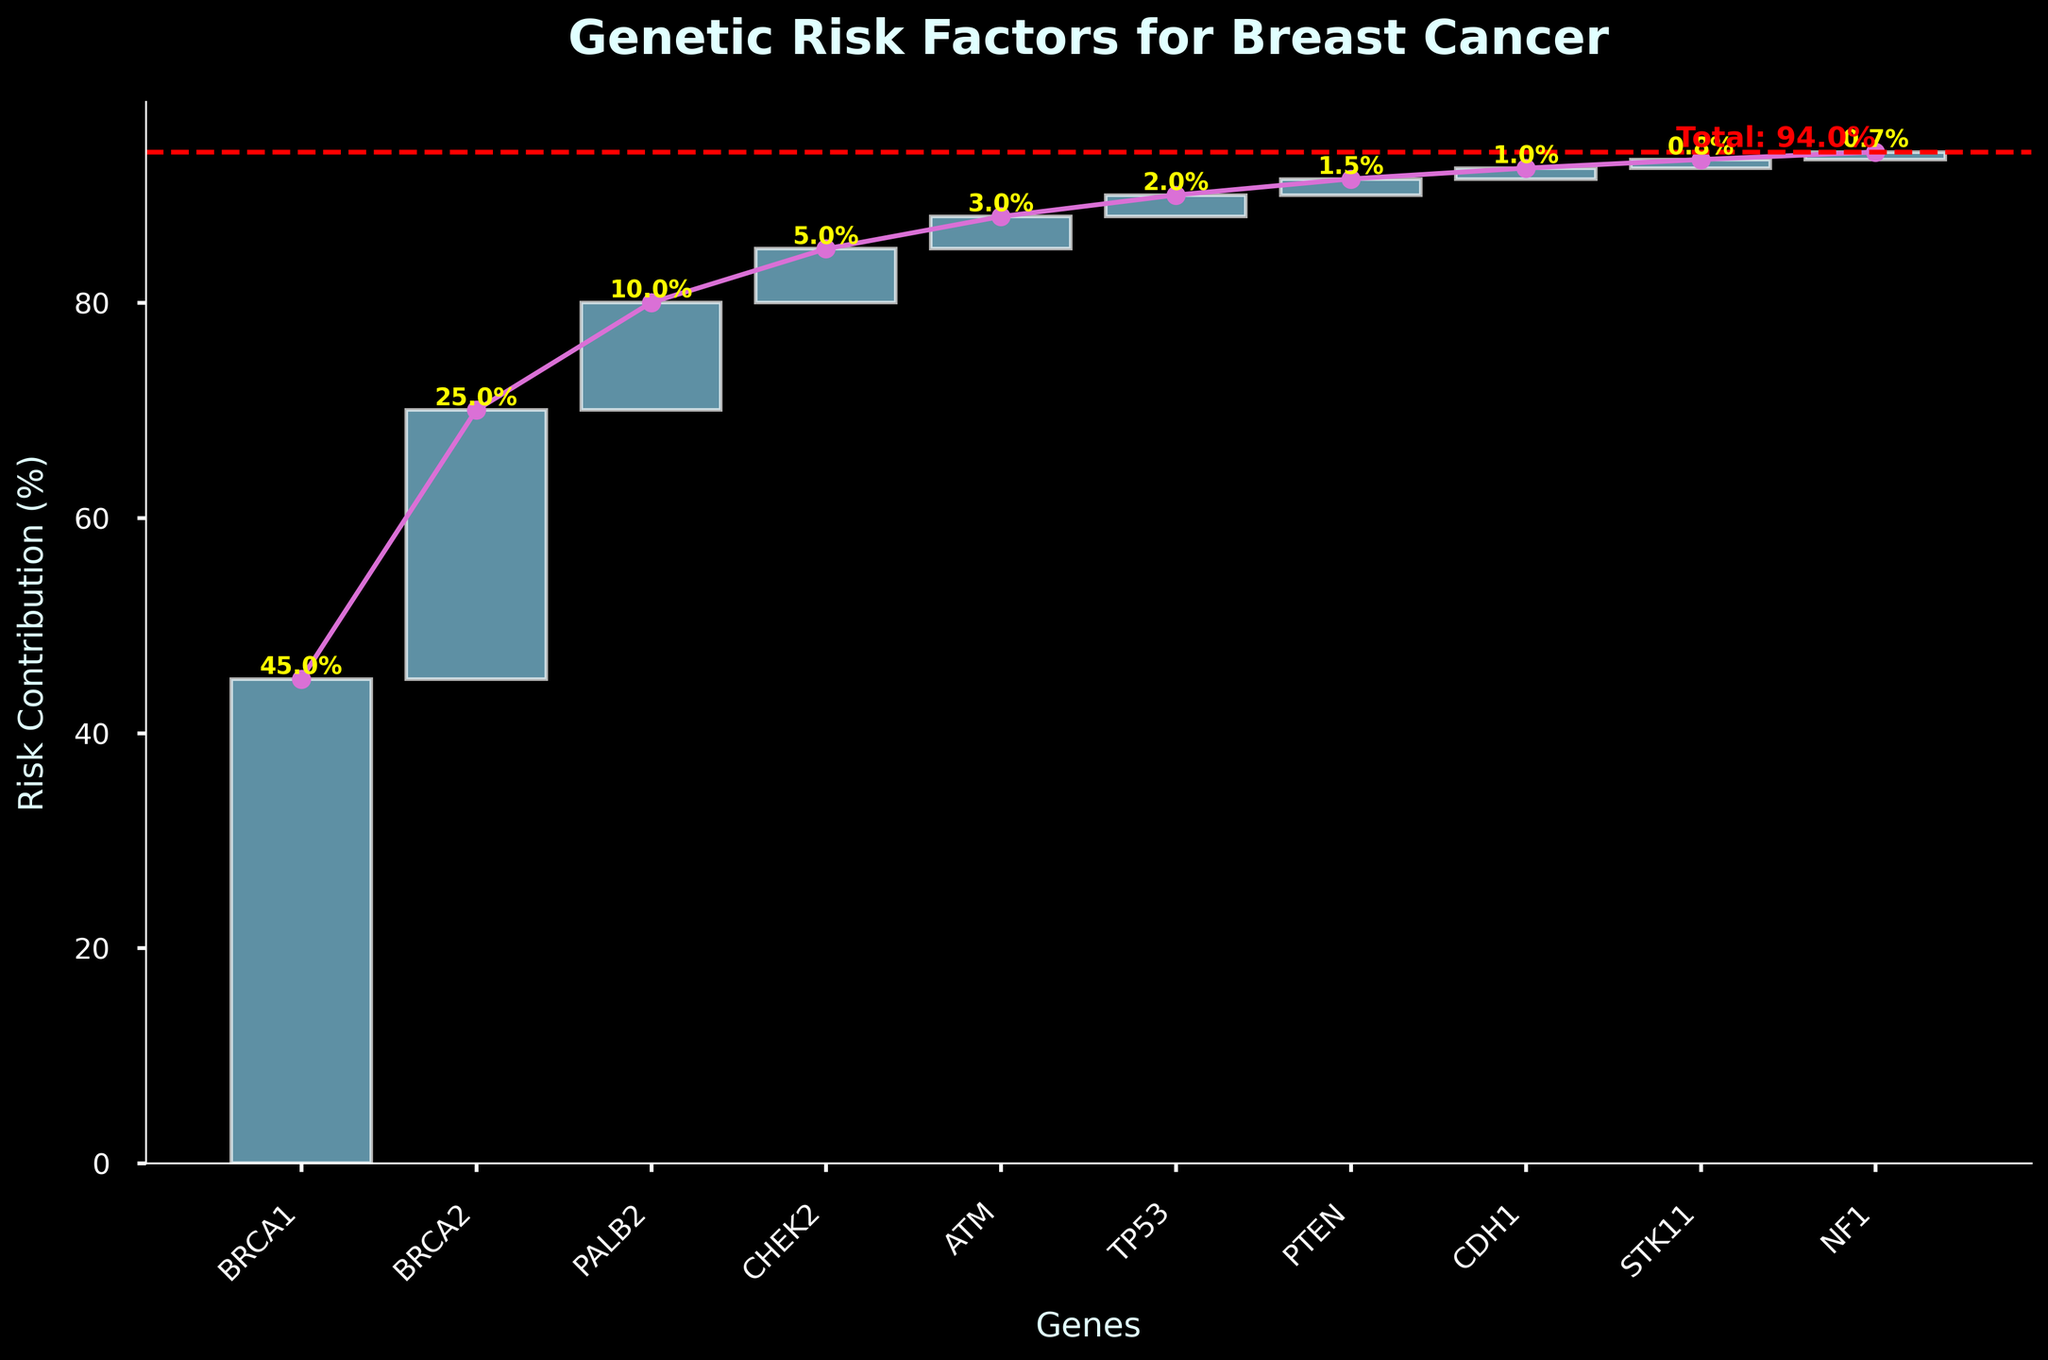Which gene has the highest risk contribution for breast cancer? The gene BRCA1 has the highest bar in the Waterfall Chart, indicating the highest risk contribution percentage.
Answer: BRCA1 What's the combined contribution of BRCA1 and BRCA2 to breast cancer risk? BRCA1 contributes 45% and BRCA2 contributes 25%. Adding these together gives 45 + 25 = 70.
Answer: 70% How many genes have a risk contribution of 2% or less? The genes TP53 (2%), PTEN (1.5%), CDH1 (1%), STK11 (0.8%), and NF1 (0.7%) each have risk contributions of 2% or less. In total, there are 5 genes.
Answer: 5 Which gene has the smallest contribution to breast cancer risk? The gene NF1, with a contribution of 0.7%, has the smallest contribution.
Answer: NF1 By how much does PALB2's contribution exceed that of CHEK2? PALB2 has a contribution of 10%, and CHEK2 has a contribution of 5%. Subtracting these values gives 10 - 5 = 5.
Answer: 5% What is the total cumulative risk contribution shown at the end of the chart? The total cumulative risk contribution is indicated by the red dashed line and is labeled as 'Total: 94%'.
Answer: 94% How does the cumulative contribution change from CHEK2 to ATM? The cumulative risk after CHEK2 is 85% (sum of values up to CHEK2), and ATM contributes an additional 3%. The new cumulative risk contribution is 85 + 3 = 88%.
Answer: 88% What is the average risk contribution of the listed genes (excluding the total)? Sum the contributions of all listed genes (45 + 25 + 10 + 5 + 3 + 2 + 1.5 + 1 + 0.8 + 0.7 = 94). The number of genes is 10. Average = 94 / 10 = 9.4.
Answer: 9.4% Which genes have a risk contribution that is greater than the average risk contribution? The average is 9.4%. BRCA1 (45%), BRCA2 (25%), and PALB2 (10%) have contributions greater than the average.
Answer: BRCA1, BRCA2, PALB2 What's the cumulative risk contribution just before adding the gene with the highest risk? The gene BRCA1 has the highest risk contribution of 45%. Before adding BRCA1, the cumulative risk is 0%.
Answer: 0% 